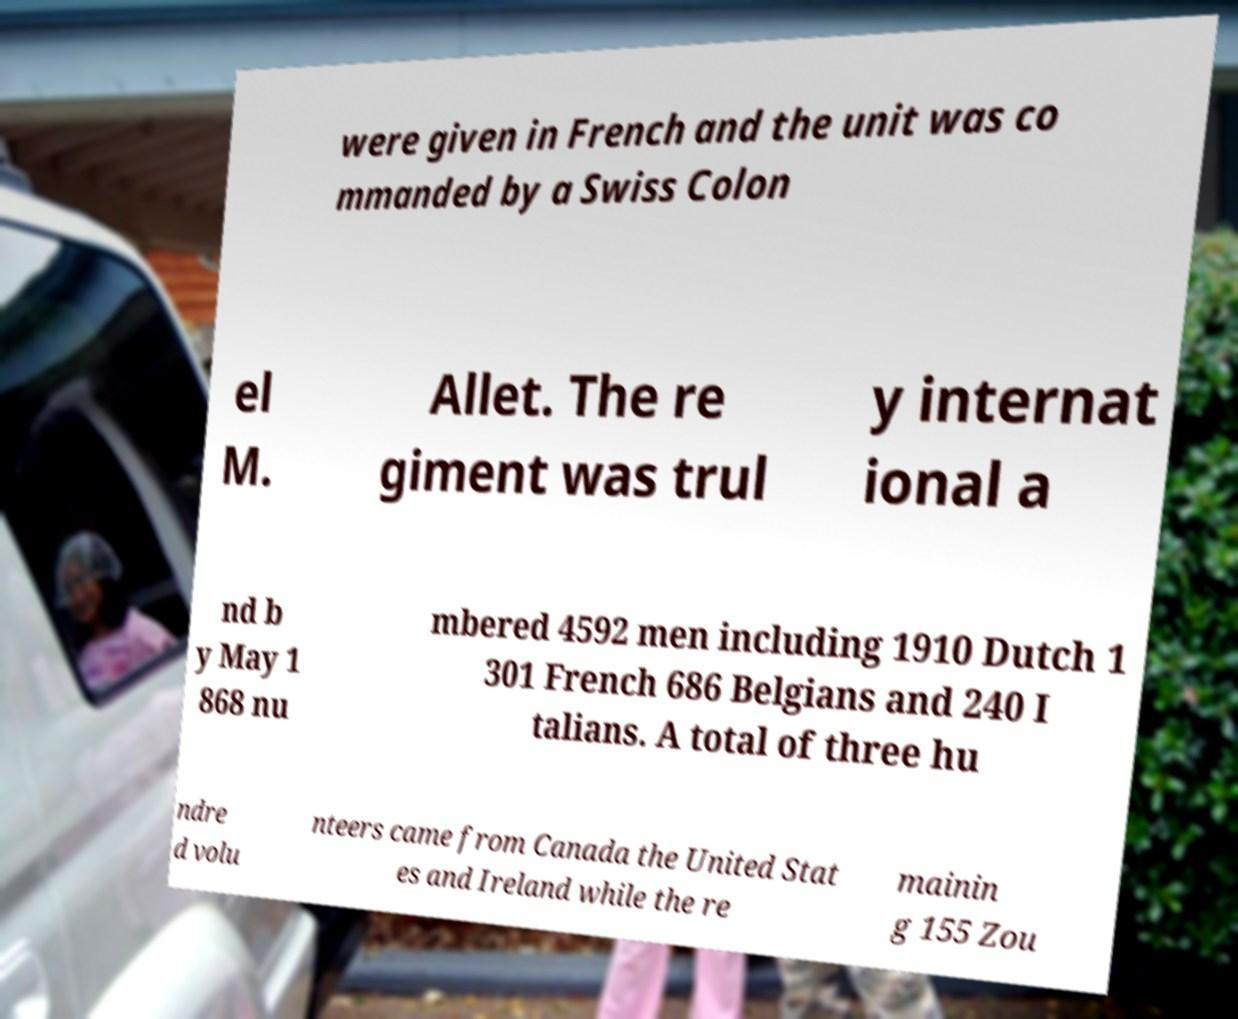I need the written content from this picture converted into text. Can you do that? were given in French and the unit was co mmanded by a Swiss Colon el M. Allet. The re giment was trul y internat ional a nd b y May 1 868 nu mbered 4592 men including 1910 Dutch 1 301 French 686 Belgians and 240 I talians. A total of three hu ndre d volu nteers came from Canada the United Stat es and Ireland while the re mainin g 155 Zou 